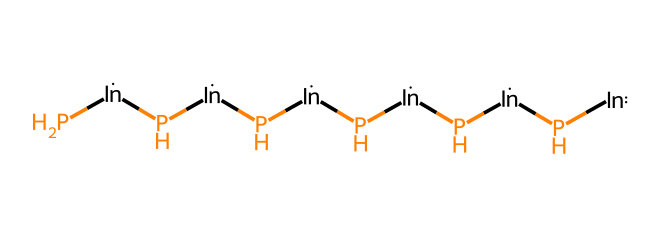What is the total number of atoms in this quantum dot? The SMILES representation shows repeated units, indicating each unit represents a distinct atom. In the representation "[In]P[In]P[In]P[In]P[In]P[In]P", there are four indium atoms (In) and three phosphorus atoms (P), totaling seven atoms.
Answer: seven What is the ratio of indium to phosphorus in this chemical? The SMILES representation reveals four indium atoms and three phosphorus atoms. The ratio can be calculated by dividing the number of indium atoms by the number of phosphorus atoms, giving a ratio of 4:3.
Answer: four to three What type of bond is primarily present in indium phosphide quantum dots? Indium phosphide is typically characterized by covalent bonding due to the sharing of electrons between indium and phosphorus atoms in the structure.
Answer: covalent What is the significance of the quantum dots in security applications? Quantum dots, like indium phosphide, provide unique photonic properties, making them useful for advanced imaging and sensing technologies in security applications.
Answer: imaging and sensing technologies How many unique chemical elements are present in this quantum dot? From the SMILES representation, there are two distinct chemical elements: indium (In) and phosphorus (P). Therefore, the number of unique elements is two.
Answer: two 